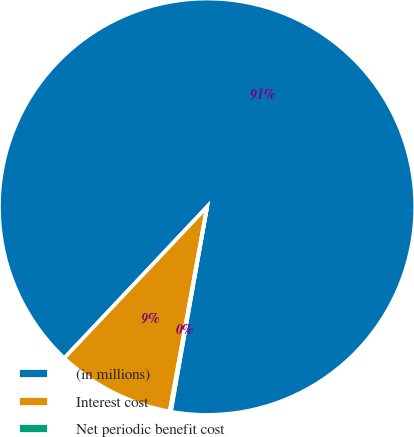Convert chart. <chart><loc_0><loc_0><loc_500><loc_500><pie_chart><fcel>(in millions)<fcel>Interest cost<fcel>Net periodic benefit cost<nl><fcel>90.75%<fcel>9.16%<fcel>0.09%<nl></chart> 